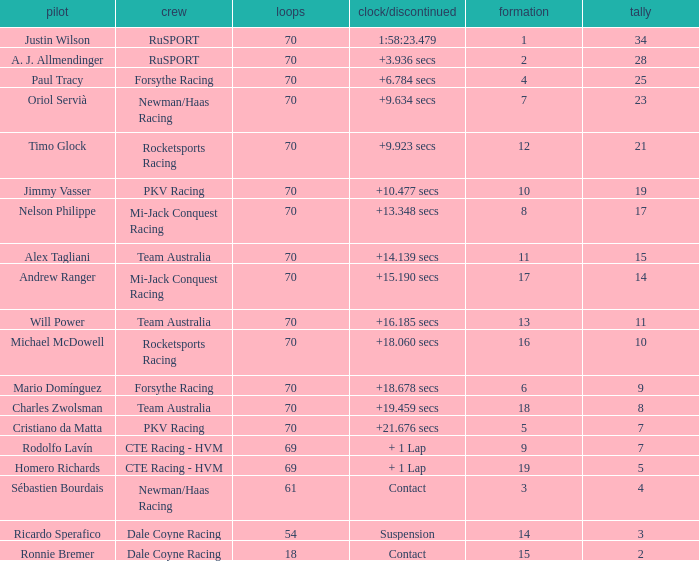Who scored with a grid of 10 and the highest amount of laps? 70.0. 